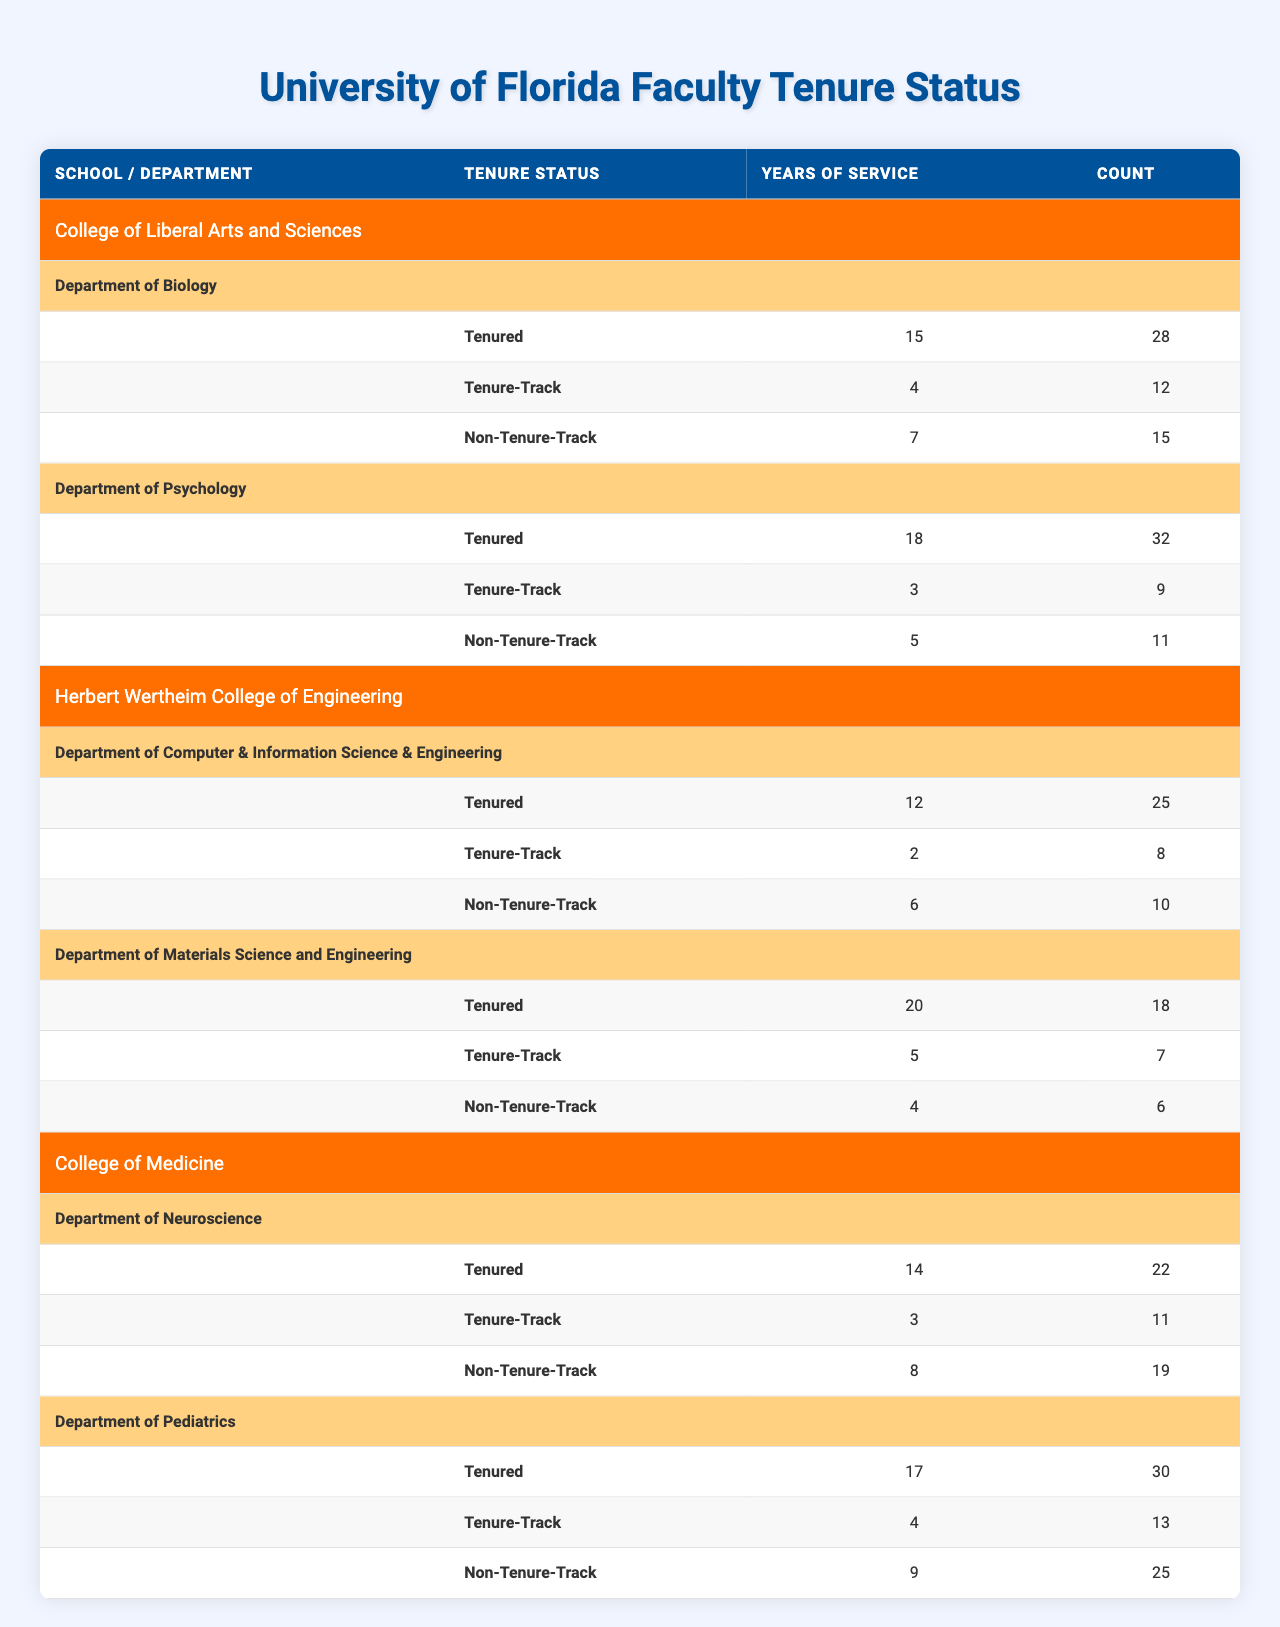What is the total count of tenured faculty in the College of Liberal Arts and Sciences? In the College of Liberal Arts and Sciences, the Department of Biology has 28 tenured faculty and the Department of Psychology has 32. So, total count = 28 + 32 = 60.
Answer: 60 What is the average years of service for non-tenure-track faculty in the Herbert Wertheim College of Engineering? In the Herbert Wertheim College of Engineering, the Department of Computer & Information Science & Engineering has 6 years and the Department of Materials Science and Engineering has 4 years of service. The average is (6 + 4) / 2 = 5.
Answer: 5 How many faculty members are tenure-track in the College of Medicine? The Department of Neuroscience has 11 tenure-track faculty and the Department of Pediatrics has 13. So, total count = 11 + 13 = 24.
Answer: 24 Which department has the highest count of tenured faculty? Looking at the data, the Department of Psychology in the College of Liberal Arts and Sciences has 32 tenured faculty, which is the highest count compared to other departments.
Answer: Department of Psychology Is there a non-tenure-track faculty member in the Department of Materials Science and Engineering? Yes, the Department has 6 non-tenure-track faculty, which confirms that there are non-tenure-track members in that department.
Answer: Yes What is the difference in the average years of service between tenured and non-tenure-track faculty across all schools? Summing up the years of service: Tenured (14+17+15+18+12+20) = 96 years divided by 6 = 16 (average for tenured), Non-Tenure (8+9+7+5+6+4) = 39 years divided by 6 = 6.5 (average for non-tenured). The difference = 16 - 6.5 = 9.5.
Answer: 9.5 How many more tenured faculty does the College of Medicine have compared to the Herbert Wertheim College of Engineering? The College of Medicine has 52 tenured faculty (22 from Neuroscience and 30 from Pediatrics), while the Herbert Wertheim College of Engineering has 43 tenured faculty (25 from Computer & Information Science & Engineering and 18 from Materials Science and Engineering). The difference is 52 - 43 = 9.
Answer: 9 What is the total count of faculty in the Department of Biology? The Department of Biology has tenured (28), tenure-track (12), and non-tenure-track (15) faculty. So, total count = 28 + 12 + 15 = 55.
Answer: 55 What is the average years of service for tenured faculty across all departments? The total years of service for tenured faculty are (15 + 18 + 12 + 20 + 14 + 17) = 96, and there are 6 tenured faculty groups. The average years of service = 96 / 6 = 16.
Answer: 16 